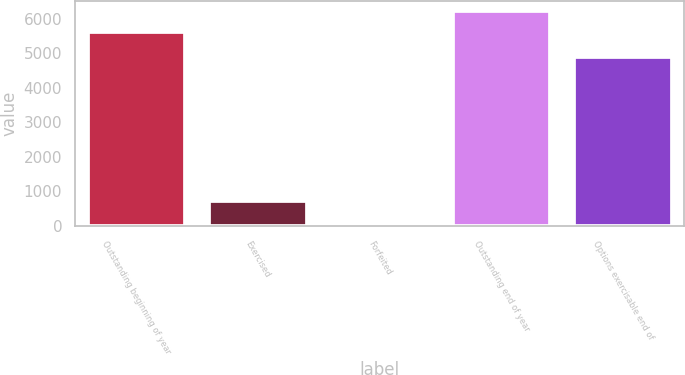<chart> <loc_0><loc_0><loc_500><loc_500><bar_chart><fcel>Outstanding beginning of year<fcel>Exercised<fcel>Forfeited<fcel>Outstanding end of year<fcel>Options exercisable end of<nl><fcel>5622<fcel>720<fcel>52<fcel>6217.6<fcel>4892<nl></chart> 